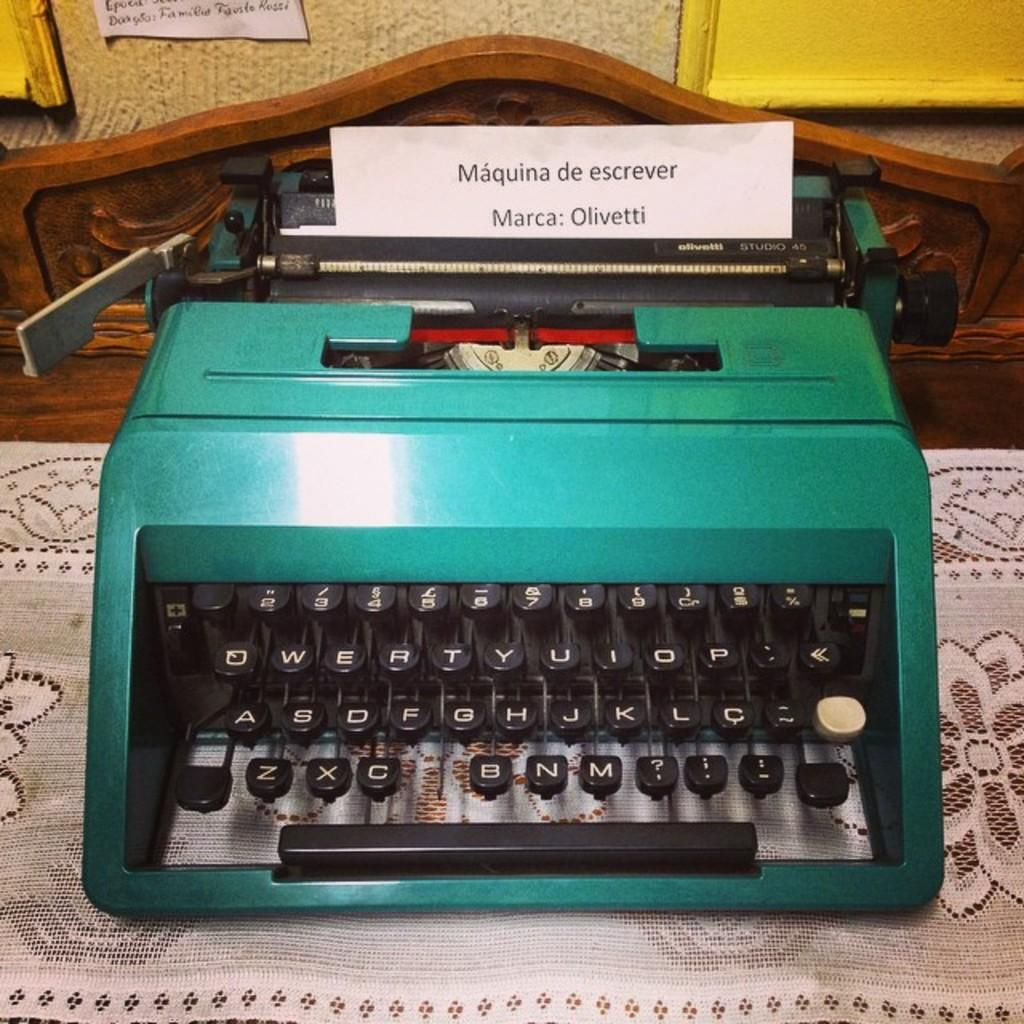<image>
Provide a brief description of the given image. A piece of paper in a typewriter has the words Marca: Olivetti printed on it. 